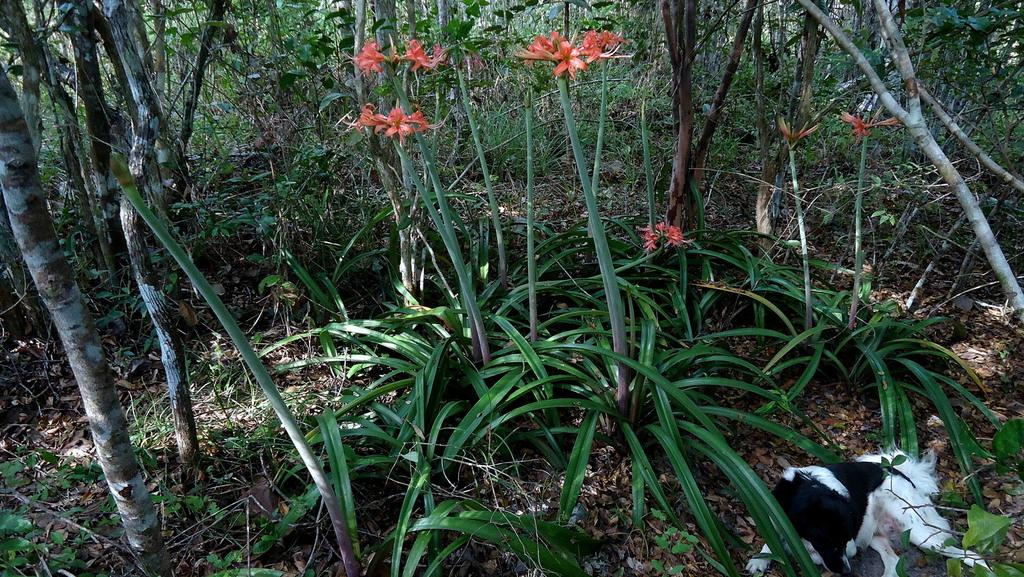What type of environment is depicted in the image? The image appears to depict a forest. What can be observed in the image besides the forest environment? There are many plants and flowers visible in the image. What type of vegetation can be seen in the background of the image? There are trees in the background of the image. Can you describe the animal present in the image? A dog is laying on the ground in the bottom right of the image. Where is the drain located in the image? There is no drain present in the image. What type of container is the dog sitting in the image? The dog is laying on the ground, not in a container, in the bottom right of the image. 